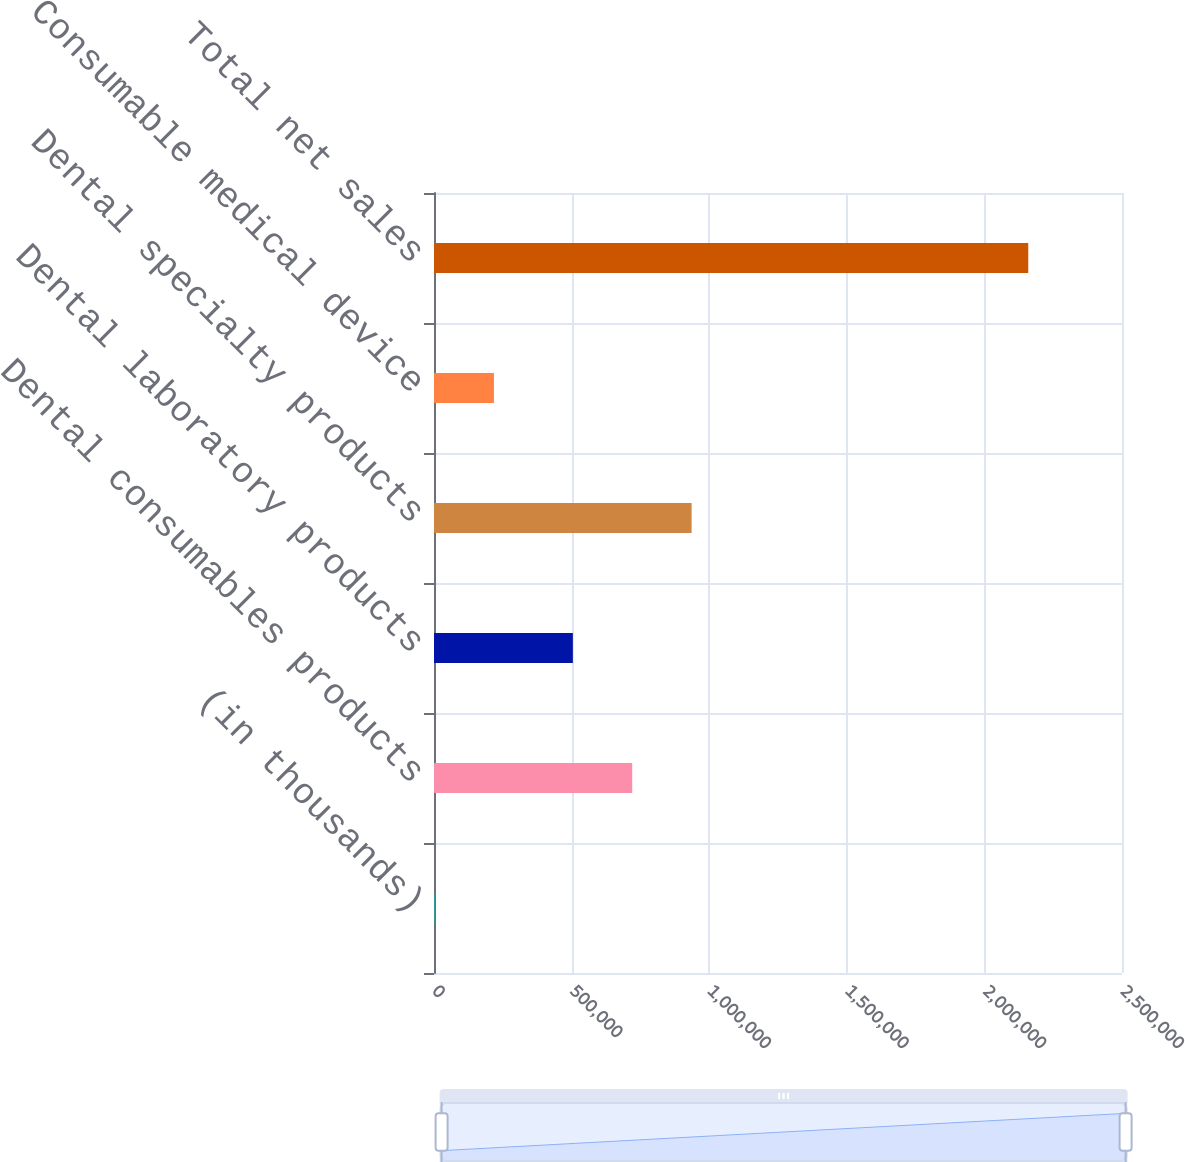Convert chart. <chart><loc_0><loc_0><loc_500><loc_500><bar_chart><fcel>(in thousands)<fcel>Dental consumables products<fcel>Dental laboratory products<fcel>Dental specialty products<fcel>Consumable medical device<fcel>Total net sales<nl><fcel>2009<fcel>720263<fcel>504526<fcel>936000<fcel>217746<fcel>2.15938e+06<nl></chart> 